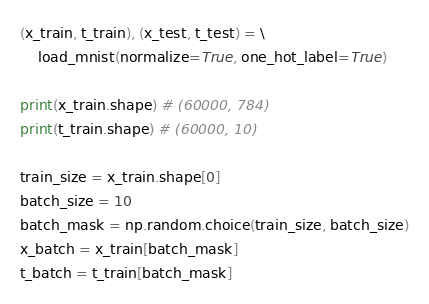<code> <loc_0><loc_0><loc_500><loc_500><_Python_>(x_train, t_train), (x_test, t_test) = \
    load_mnist(normalize=True, one_hot_label=True)

print(x_train.shape) # (60000, 784)
print(t_train.shape) # (60000, 10)

train_size = x_train.shape[0]
batch_size = 10
batch_mask = np.random.choice(train_size, batch_size)
x_batch = x_train[batch_mask]
t_batch = t_train[batch_mask]
</code> 